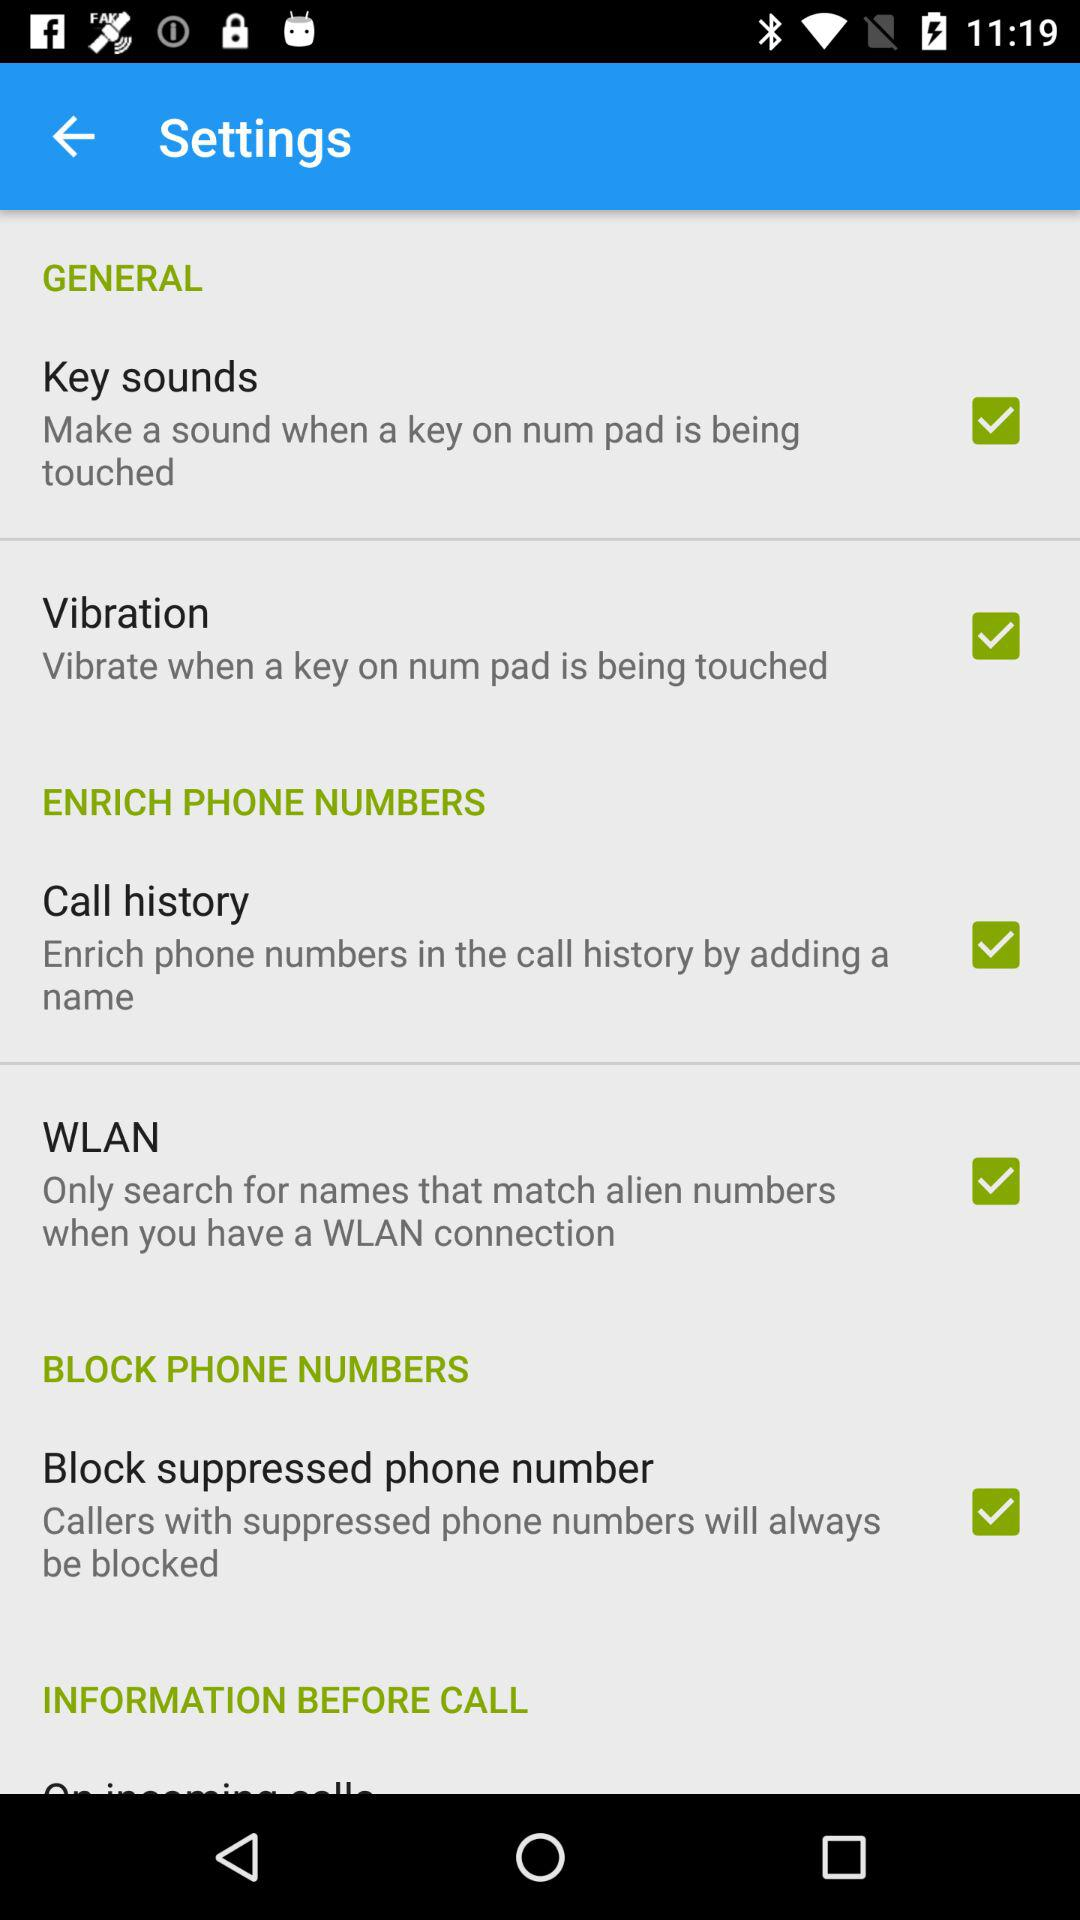What is the setting for "BLOCK PHONE NUMBERS"? The setting is "Block suppressed phone number". 